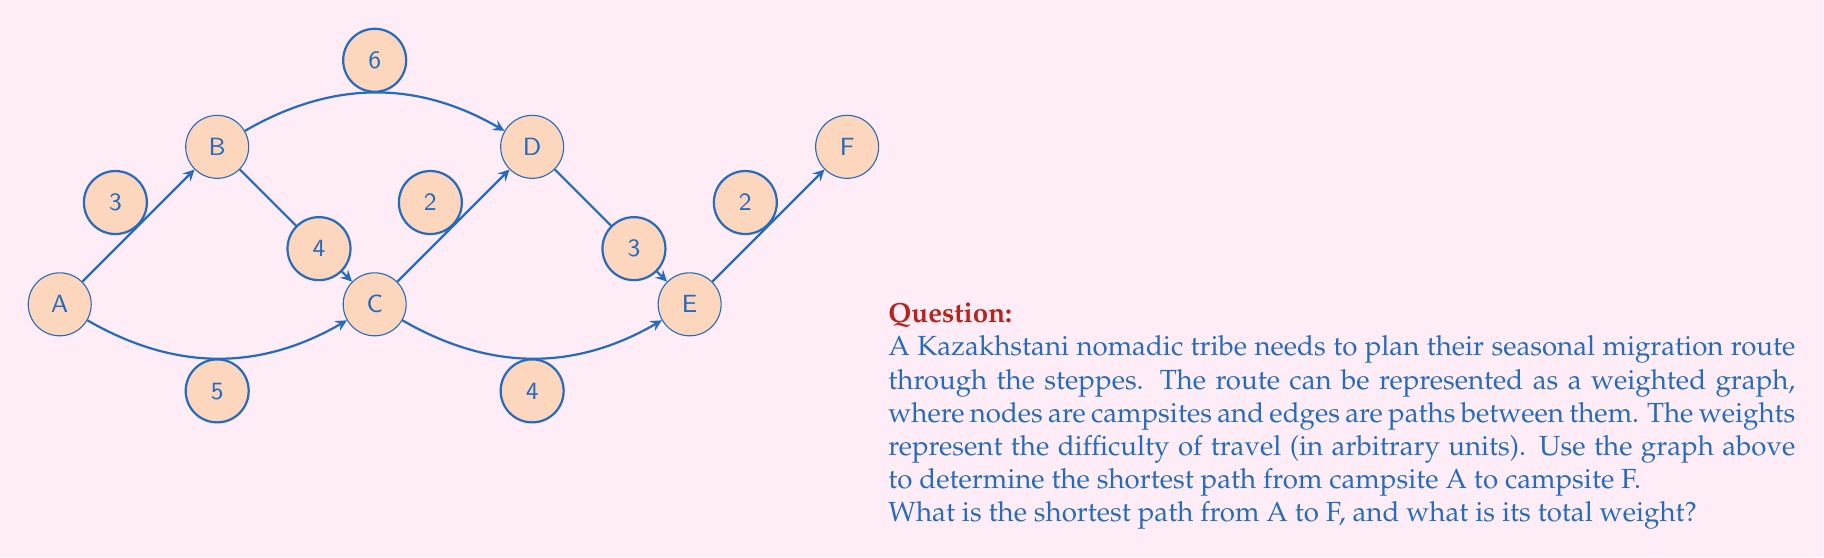Show me your answer to this math problem. To solve this problem, we can use Dijkstra's algorithm, which is efficient for finding the shortest path in a weighted graph.

Step 1: Initialize distances
Set distance to A as 0 and all other nodes as infinity.
$d(A) = 0$, $d(B) = d(C) = d(D) = d(E) = d(F) = \infty$

Step 2: Visit node A
Update distances:
$d(B) = 3$, $d(C) = 5$

Step 3: Visit node B (closest unvisited node)
Update distances:
$d(C) = \min(5, 3+4) = 5$, $d(D) = 3+6 = 9$

Step 4: Visit node C
Update distances:
$d(D) = \min(9, 5+2) = 7$, $d(E) = 5+4 = 9$

Step 5: Visit node D
Update distances:
$d(E) = \min(9, 7+3) = 9$, $d(F) = 7+2 = 9$

Step 6: Visit node F (closer than E)
Algorithm terminates as we've reached the destination.

The shortest path is A → B → C → D → F with a total weight of 9.
Answer: A → B → C → D → F, weight = 9 